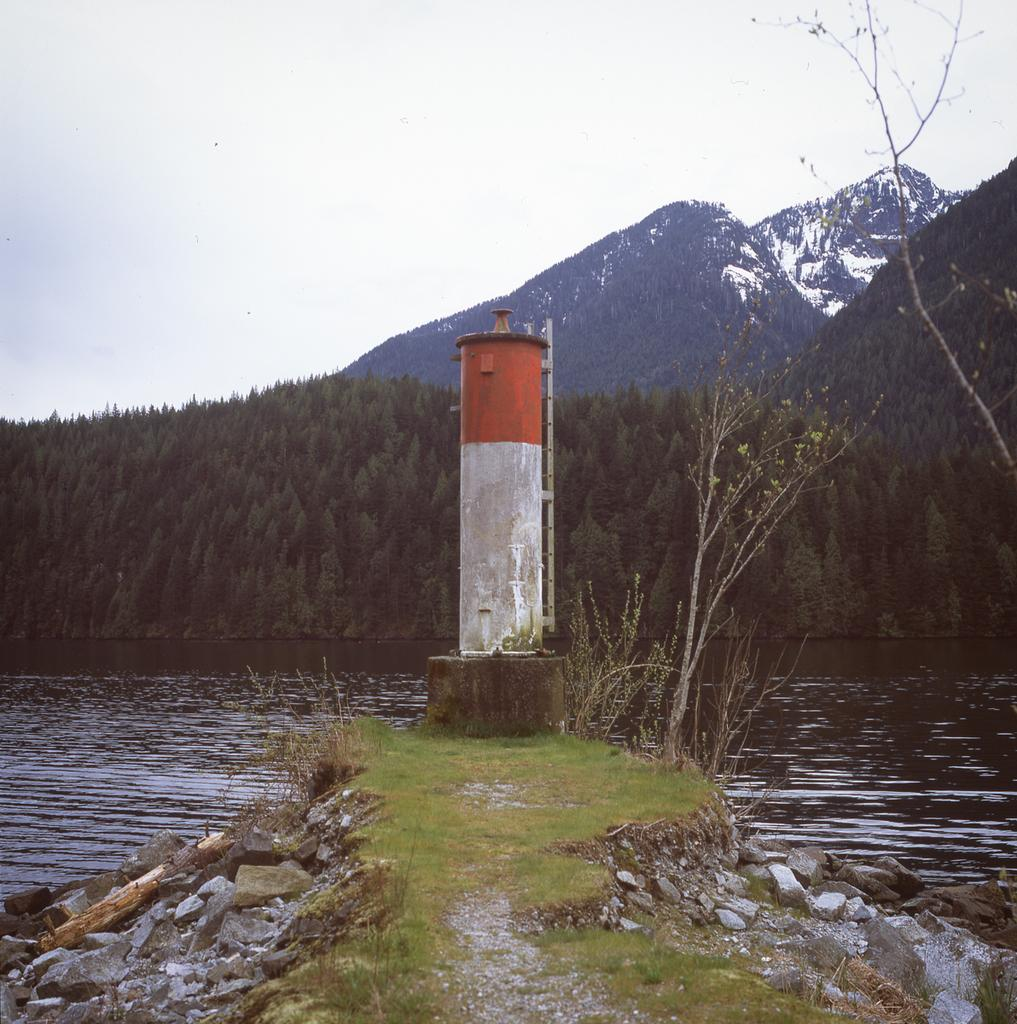What type of natural elements can be seen in the image? There are rocks and water visible in the image. What man-made structure is present in the image? There is a tower in the image. What can be seen in the background of the image? There are trees and hills in the background of the image. What type of sponge is being used to create harmony in the image? There is no sponge or indication of harmony present in the image. 